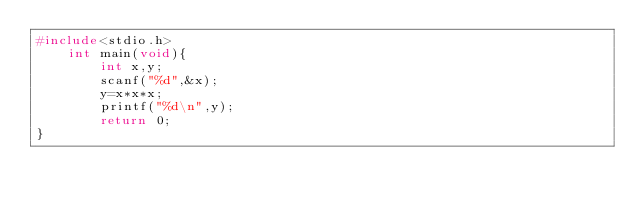Convert code to text. <code><loc_0><loc_0><loc_500><loc_500><_C_>#include<stdio.h>
    int main(void){
        int x,y;
        scanf("%d",&x);
        y=x*x*x;
        printf("%d\n",y);
        return 0;
}</code> 